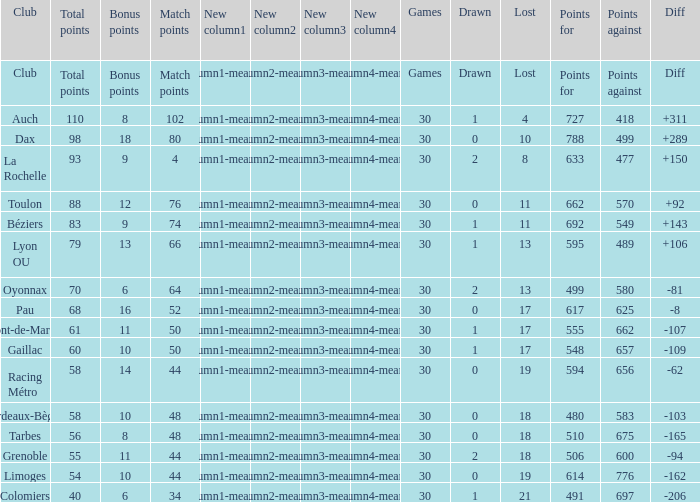What is the diff for a club that has a value of 662 for points for? 92.0. 